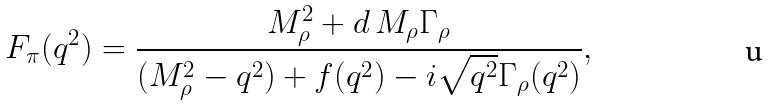<formula> <loc_0><loc_0><loc_500><loc_500>F _ { \pi } ( q ^ { 2 } ) = \frac { M _ { \rho } ^ { 2 } + d \, M _ { \rho } \Gamma _ { \rho } } { ( M _ { \rho } ^ { 2 } - q ^ { 2 } ) + f ( q ^ { 2 } ) - i \sqrt { q ^ { 2 } } \Gamma _ { \rho } ( q ^ { 2 } ) } ,</formula> 